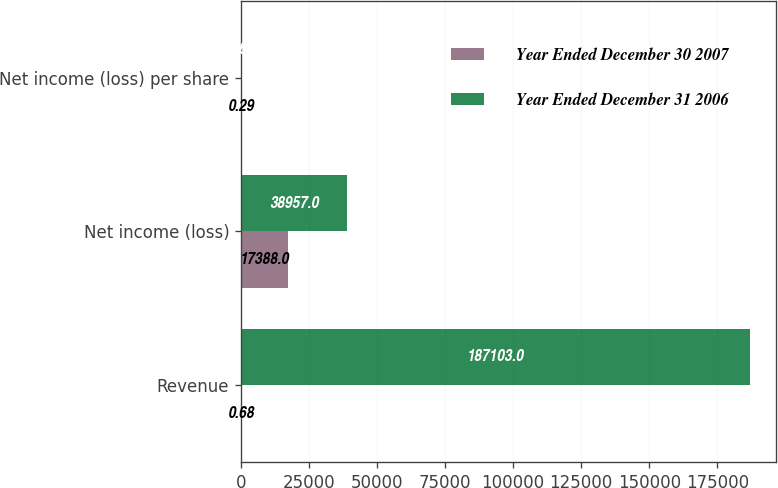Convert chart. <chart><loc_0><loc_0><loc_500><loc_500><stacked_bar_chart><ecel><fcel>Revenue<fcel>Net income (loss)<fcel>Net income (loss) per share<nl><fcel>Year Ended December 30 2007<fcel>0.68<fcel>17388<fcel>0.29<nl><fcel>Year Ended December 31 2006<fcel>187103<fcel>38957<fcel>0.68<nl></chart> 